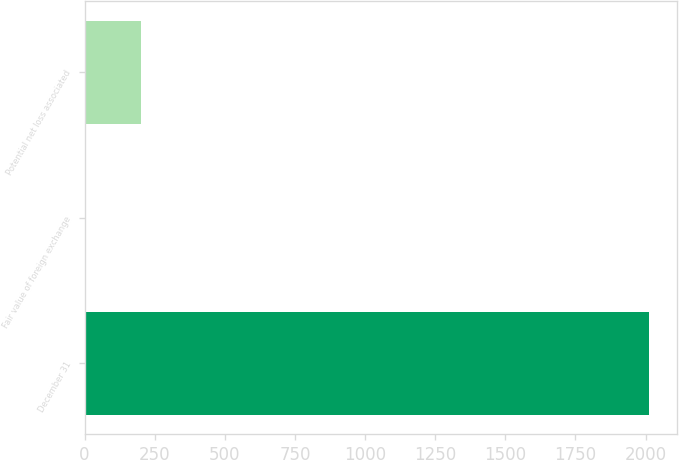Convert chart to OTSL. <chart><loc_0><loc_0><loc_500><loc_500><bar_chart><fcel>December 31<fcel>Fair value of foreign exchange<fcel>Potential net loss associated<nl><fcel>2011<fcel>1.4<fcel>202.36<nl></chart> 